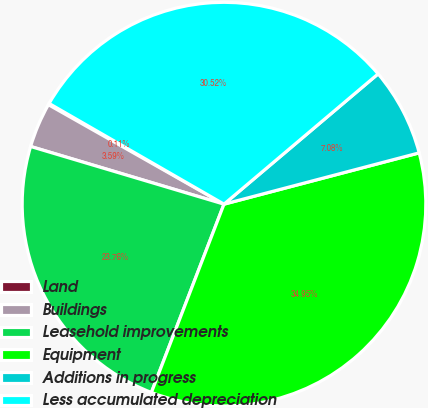Convert chart. <chart><loc_0><loc_0><loc_500><loc_500><pie_chart><fcel>Land<fcel>Buildings<fcel>Leasehold improvements<fcel>Equipment<fcel>Additions in progress<fcel>Less accumulated depreciation<nl><fcel>0.11%<fcel>3.59%<fcel>23.76%<fcel>34.95%<fcel>7.08%<fcel>30.52%<nl></chart> 